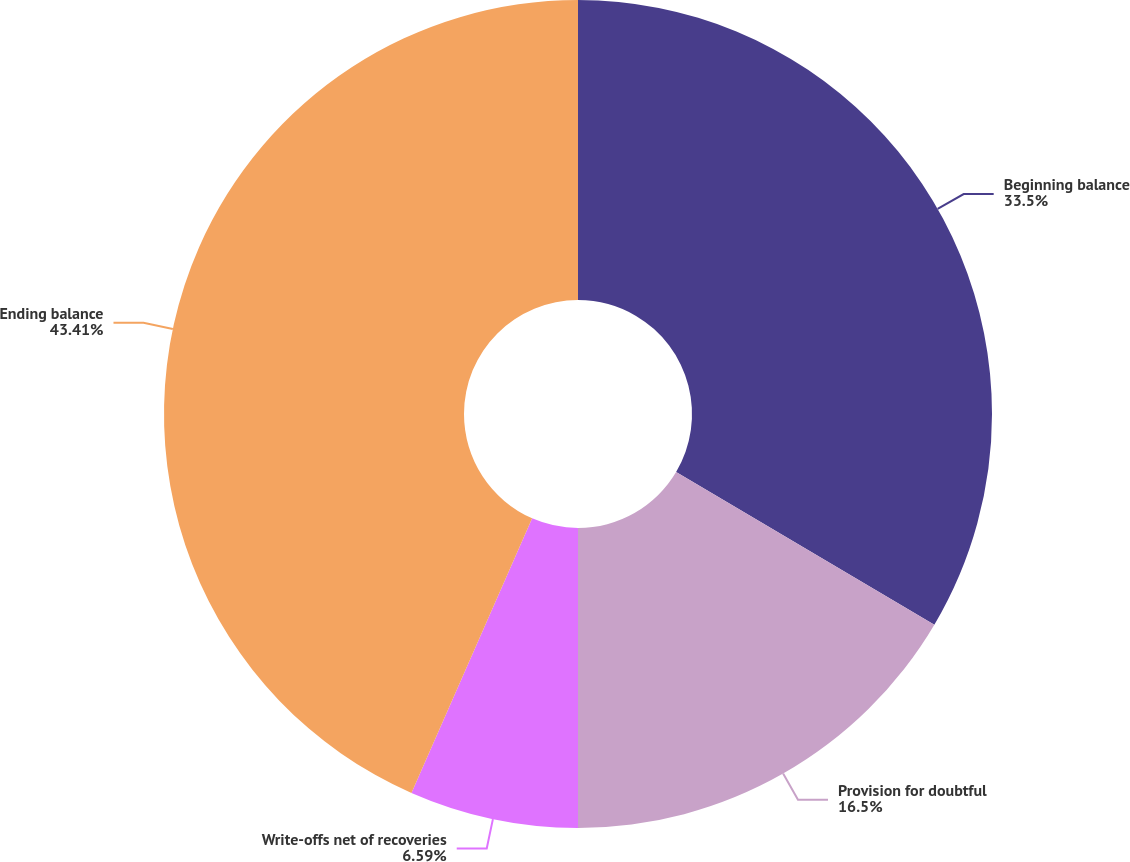Convert chart. <chart><loc_0><loc_0><loc_500><loc_500><pie_chart><fcel>Beginning balance<fcel>Provision for doubtful<fcel>Write-offs net of recoveries<fcel>Ending balance<nl><fcel>33.5%<fcel>16.5%<fcel>6.59%<fcel>43.41%<nl></chart> 